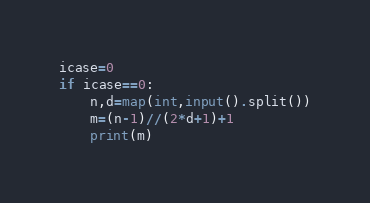Convert code to text. <code><loc_0><loc_0><loc_500><loc_500><_Python_>icase=0
if icase==0:
    n,d=map(int,input().split())
    m=(n-1)//(2*d+1)+1
    print(m)</code> 